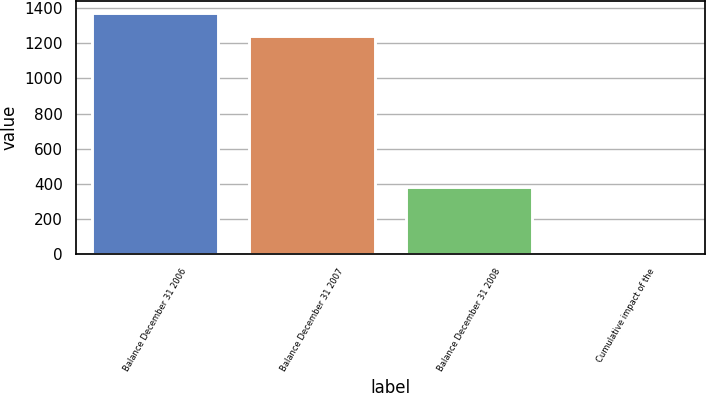Convert chart to OTSL. <chart><loc_0><loc_0><loc_500><loc_500><bar_chart><fcel>Balance December 31 2006<fcel>Balance December 31 2007<fcel>Balance December 31 2008<fcel>Cumulative impact of the<nl><fcel>1374.4<fcel>1242<fcel>384<fcel>4<nl></chart> 